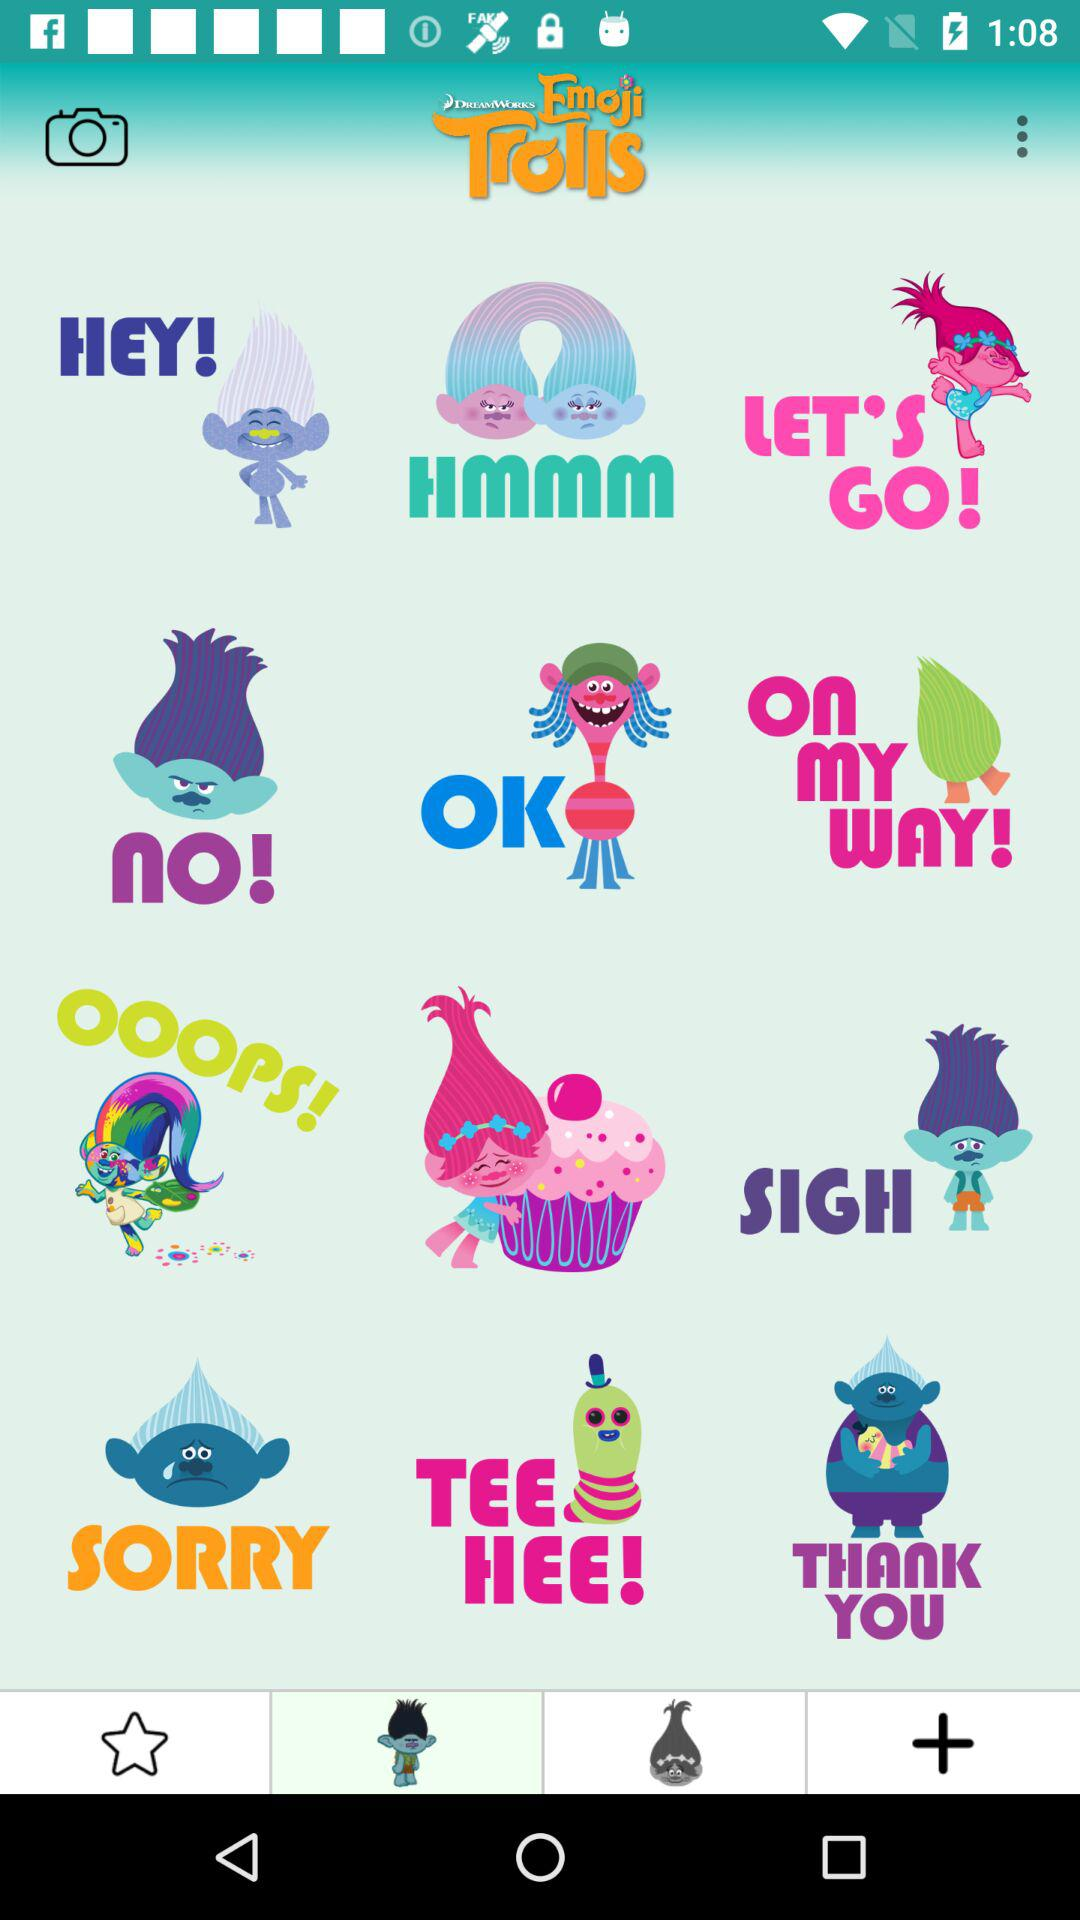What is the application name? The application name is "Emoji Trolls". 